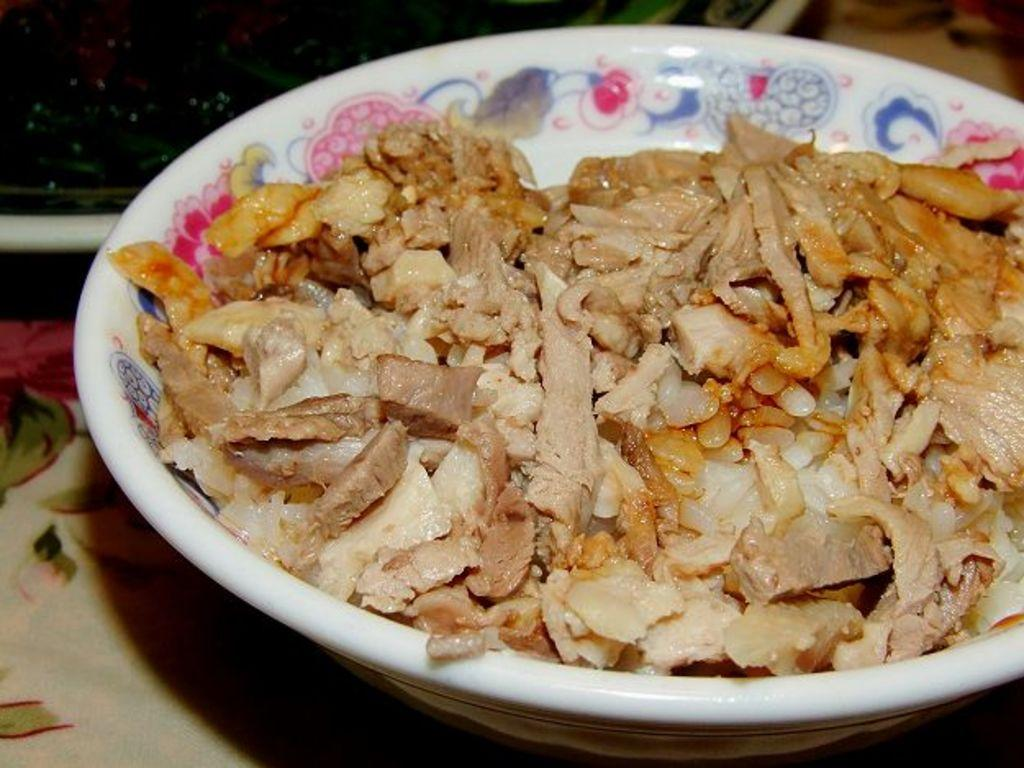What type of furniture is present in the image? There is a table in the image. How is the table decorated or covered? The table is covered with a cloth. What is on top of the table? There is a bowl on the table. What is inside the bowl? The bowl contains a food item. Are there any other objects on the table? Yes, there are other objects on the table. What type of jeans is the bowl wearing in the image? The bowl is not wearing jeans, as it is an inanimate object and does not have the ability to wear clothing. 